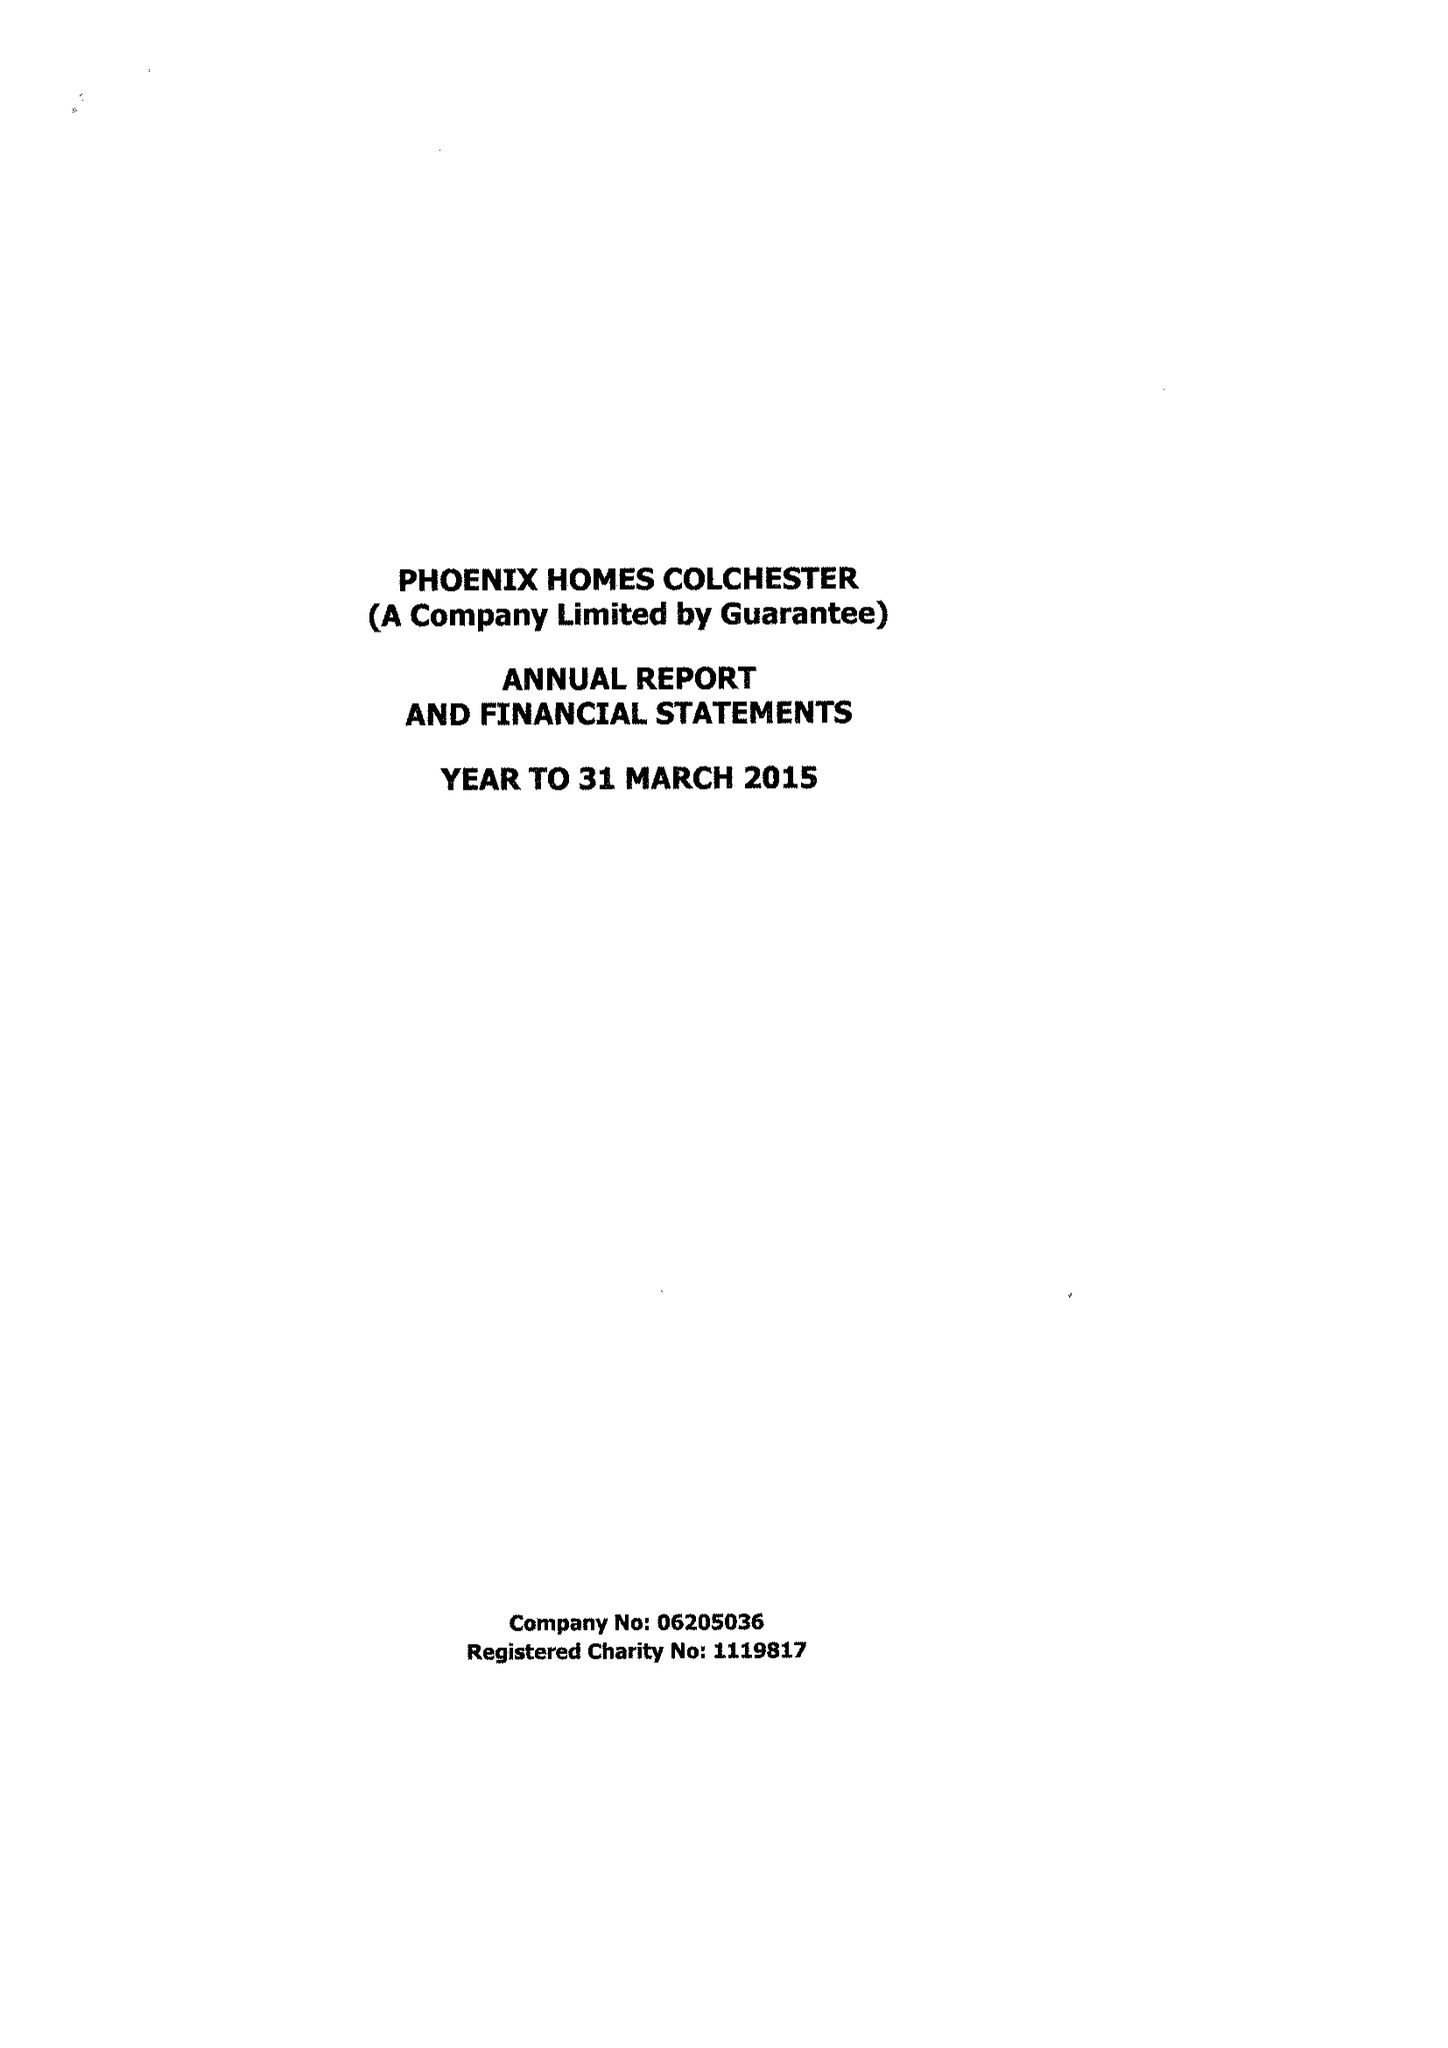What is the value for the report_date?
Answer the question using a single word or phrase. 2015-03-31 